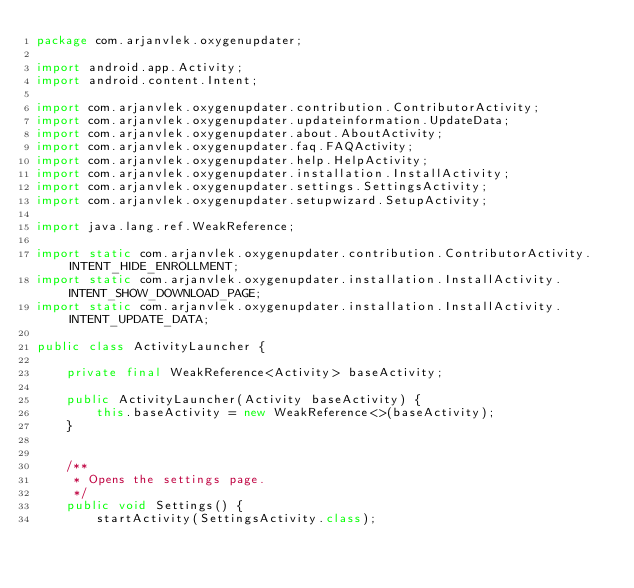Convert code to text. <code><loc_0><loc_0><loc_500><loc_500><_Java_>package com.arjanvlek.oxygenupdater;

import android.app.Activity;
import android.content.Intent;

import com.arjanvlek.oxygenupdater.contribution.ContributorActivity;
import com.arjanvlek.oxygenupdater.updateinformation.UpdateData;
import com.arjanvlek.oxygenupdater.about.AboutActivity;
import com.arjanvlek.oxygenupdater.faq.FAQActivity;
import com.arjanvlek.oxygenupdater.help.HelpActivity;
import com.arjanvlek.oxygenupdater.installation.InstallActivity;
import com.arjanvlek.oxygenupdater.settings.SettingsActivity;
import com.arjanvlek.oxygenupdater.setupwizard.SetupActivity;

import java.lang.ref.WeakReference;

import static com.arjanvlek.oxygenupdater.contribution.ContributorActivity.INTENT_HIDE_ENROLLMENT;
import static com.arjanvlek.oxygenupdater.installation.InstallActivity.INTENT_SHOW_DOWNLOAD_PAGE;
import static com.arjanvlek.oxygenupdater.installation.InstallActivity.INTENT_UPDATE_DATA;

public class ActivityLauncher {

    private final WeakReference<Activity> baseActivity;

    public ActivityLauncher(Activity baseActivity) {
        this.baseActivity = new WeakReference<>(baseActivity);
    }


    /**
     * Opens the settings page.
     */
    public void Settings() {
        startActivity(SettingsActivity.class);</code> 